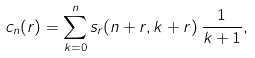Convert formula to latex. <formula><loc_0><loc_0><loc_500><loc_500>c _ { n } ( r ) = \sum _ { k = 0 } ^ { n } s _ { r } ( n + r , k + r ) \, \frac { 1 } { k + 1 } ,</formula> 